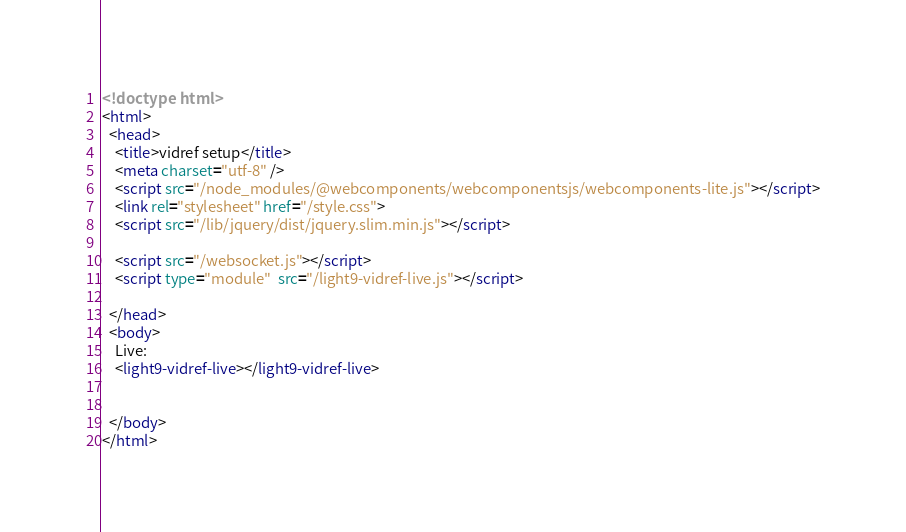Convert code to text. <code><loc_0><loc_0><loc_500><loc_500><_HTML_><!doctype html>
<html>
  <head>
    <title>vidref setup</title>
    <meta charset="utf-8" />
    <script src="/node_modules/@webcomponents/webcomponentsjs/webcomponents-lite.js"></script>
    <link rel="stylesheet" href="/style.css">
    <script src="/lib/jquery/dist/jquery.slim.min.js"></script>

    <script src="/websocket.js"></script>
    <script type="module"  src="/light9-vidref-live.js"></script>

  </head>
  <body>
    Live:
    <light9-vidref-live></light9-vidref-live>

    
  </body>
</html>
</code> 